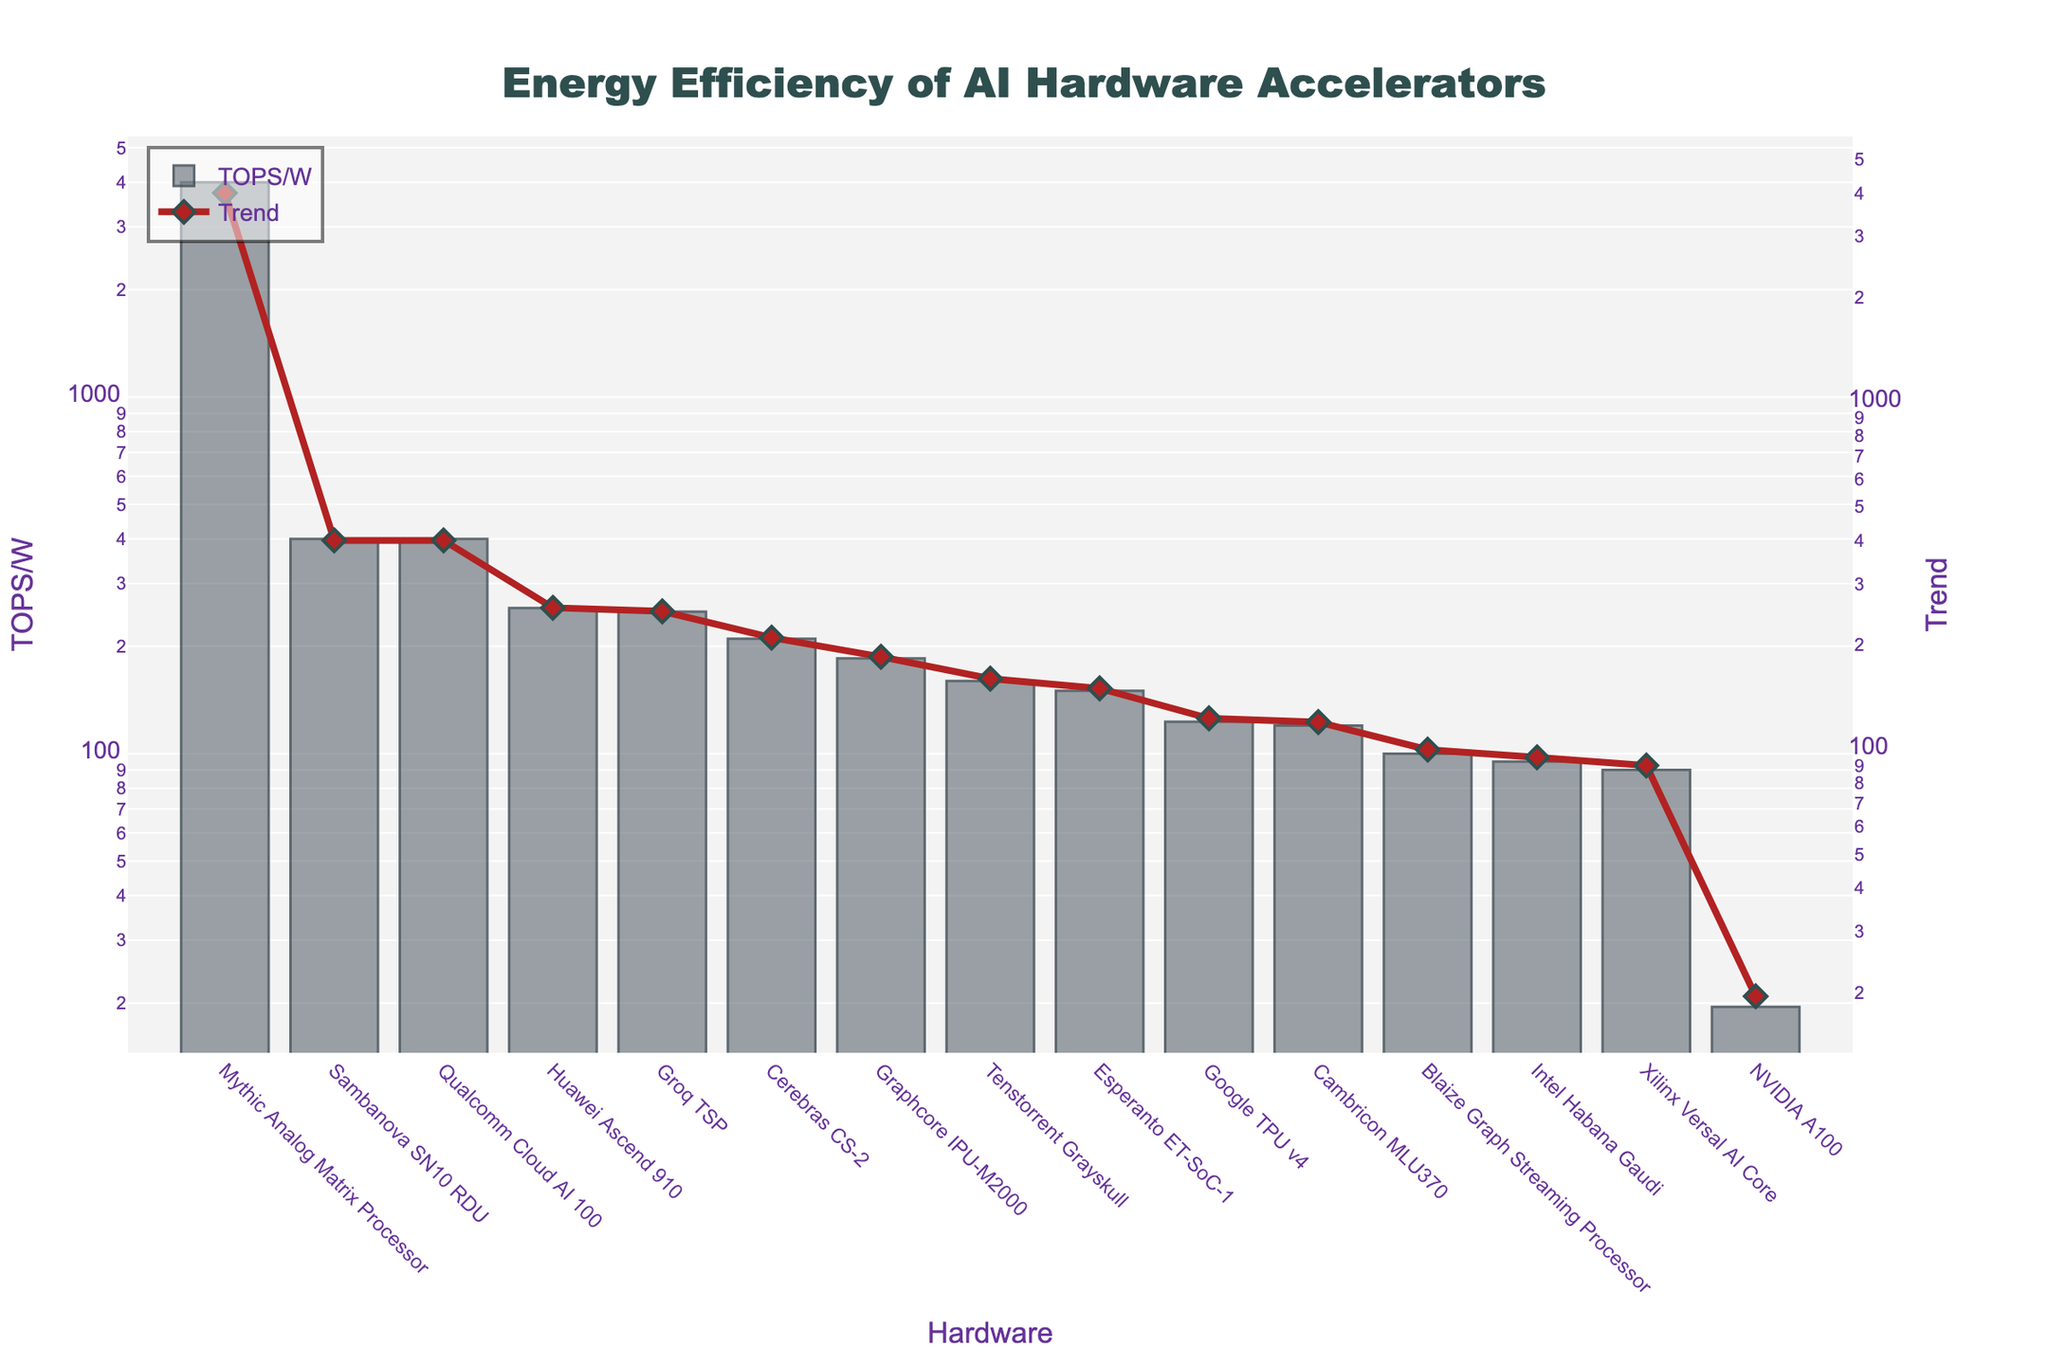Which hardware accelerator has the highest energy efficiency (TOPS/W)? The bar chart shows that the Mythic Analog Matrix Processor has the highest bar, representing the highest energy efficiency with 4000 TOPS/W.
Answer: Mythic Analog Matrix Processor What is the energy efficiency difference between the NVIDIA A100 and the Mythic Analog Matrix Processor? According to the bar heights in the chart, the NVIDIA A100 has an energy efficiency of 19.5 TOPS/W, while the Mythic Analog Matrix Processor has 4000 TOPS/W. Therefore, the difference is 4000 - 19.5 = 3980.5 TOPS/W.
Answer: 3980.5 TOPS/W How does the energy efficiency of the Google TPU v4 compare to the Cerebras CS-2? The bar chart shows that the Google TPU v4 has an energy efficiency of 123 TOPS/W, while the Cerebras CS-2 has a higher value of 210 TOPS/W. So, the Cerebras CS-2 is more energy efficient than the Google TPU v4.
Answer: Cerebras CS-2 is more efficient Which hardware accelerators have energy efficiency metrics above 300 TOPS/W? From the chart, the hardware accelerators with bars above the 300 TOPS/W mark are Mythic Analog Matrix Processor (4000), Qualcomm Cloud AI 100 (400), and Sambanova SN10 RDU (400).
Answer: Mythic Analog Matrix Processor, Qualcomm Cloud AI 100, Sambanova SN10 RDU Compare the energy efficiency of the Intel Habana Gaudi and the Groq TSP. Who has better performance, and by how much? From the chart, the Intel Habana Gaudi has 95 TOPS/W, and the Groq TSP has 250 TOPS/W. The difference in energy efficiency is 250 - 95 = 155 TOPS/W, with the Groq TSP being better.
Answer: Groq TSP, by 155 TOPS/W What is the median energy efficiency value for the given hardware accelerators? To find the median, we need to list all the TOPS/W values and find the middle one. Ordered: 19.5, 90, 95, 100, 120, 123, 150, 160, 185, 210, 250, 256, 400, 400, 4000. The median value is the 8th value in this sorted list, which is 160 TOPS/W (Tenstorrent Grayskull).
Answer: 160 TOPS/W What trend can you observe in the bars' heights and the associated scatter plot line? The bars' heights and the scatter plot line trend show an increasing pattern with the Mythic Analog Matrix Processor and high-performance accelerators exceeding significantly higher values than others.
Answer: Increasing trend 